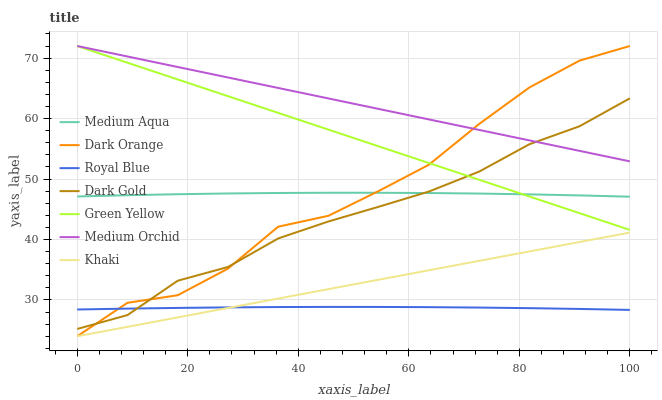Does Royal Blue have the minimum area under the curve?
Answer yes or no. Yes. Does Medium Orchid have the maximum area under the curve?
Answer yes or no. Yes. Does Khaki have the minimum area under the curve?
Answer yes or no. No. Does Khaki have the maximum area under the curve?
Answer yes or no. No. Is Khaki the smoothest?
Answer yes or no. Yes. Is Dark Orange the roughest?
Answer yes or no. Yes. Is Dark Gold the smoothest?
Answer yes or no. No. Is Dark Gold the roughest?
Answer yes or no. No. Does Dark Orange have the lowest value?
Answer yes or no. Yes. Does Dark Gold have the lowest value?
Answer yes or no. No. Does Green Yellow have the highest value?
Answer yes or no. Yes. Does Khaki have the highest value?
Answer yes or no. No. Is Royal Blue less than Medium Aqua?
Answer yes or no. Yes. Is Medium Aqua greater than Khaki?
Answer yes or no. Yes. Does Medium Aqua intersect Dark Gold?
Answer yes or no. Yes. Is Medium Aqua less than Dark Gold?
Answer yes or no. No. Is Medium Aqua greater than Dark Gold?
Answer yes or no. No. Does Royal Blue intersect Medium Aqua?
Answer yes or no. No. 